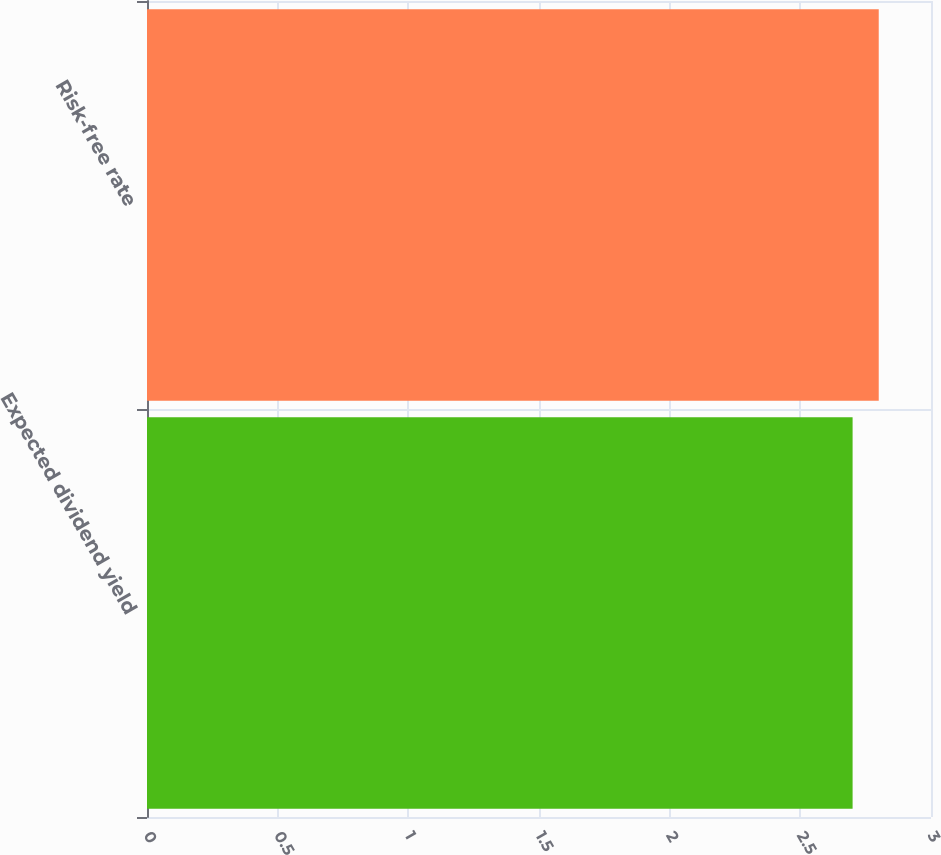Convert chart. <chart><loc_0><loc_0><loc_500><loc_500><bar_chart><fcel>Expected dividend yield<fcel>Risk-free rate<nl><fcel>2.7<fcel>2.8<nl></chart> 